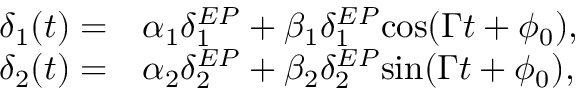Convert formula to latex. <formula><loc_0><loc_0><loc_500><loc_500>\begin{array} { r l } { \delta _ { 1 } ( t ) = } & \alpha _ { 1 } \delta _ { 1 } ^ { E P } + \beta _ { 1 } \delta _ { 1 } ^ { E P } \cos ( \Gamma t + \phi _ { 0 } ) , } \\ { \delta _ { 2 } ( t ) = } & \alpha _ { 2 } \delta _ { 2 } ^ { E P } + \beta _ { 2 } \delta _ { 2 } ^ { E P } \sin ( \Gamma t + \phi _ { 0 } ) , } \end{array}</formula> 